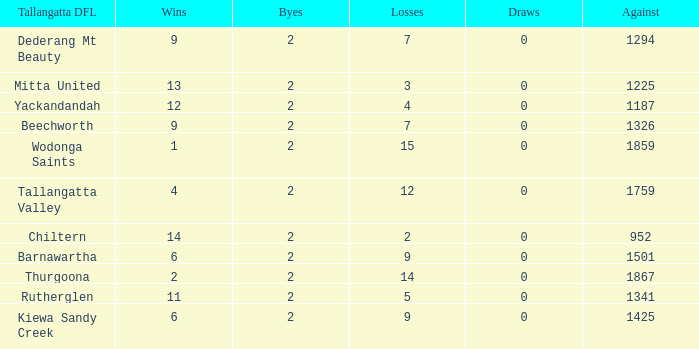What is the most byes with 11 wins and fewer than 1867 againsts? 2.0. Could you parse the entire table? {'header': ['Tallangatta DFL', 'Wins', 'Byes', 'Losses', 'Draws', 'Against'], 'rows': [['Dederang Mt Beauty', '9', '2', '7', '0', '1294'], ['Mitta United', '13', '2', '3', '0', '1225'], ['Yackandandah', '12', '2', '4', '0', '1187'], ['Beechworth', '9', '2', '7', '0', '1326'], ['Wodonga Saints', '1', '2', '15', '0', '1859'], ['Tallangatta Valley', '4', '2', '12', '0', '1759'], ['Chiltern', '14', '2', '2', '0', '952'], ['Barnawartha', '6', '2', '9', '0', '1501'], ['Thurgoona', '2', '2', '14', '0', '1867'], ['Rutherglen', '11', '2', '5', '0', '1341'], ['Kiewa Sandy Creek', '6', '2', '9', '0', '1425']]} 